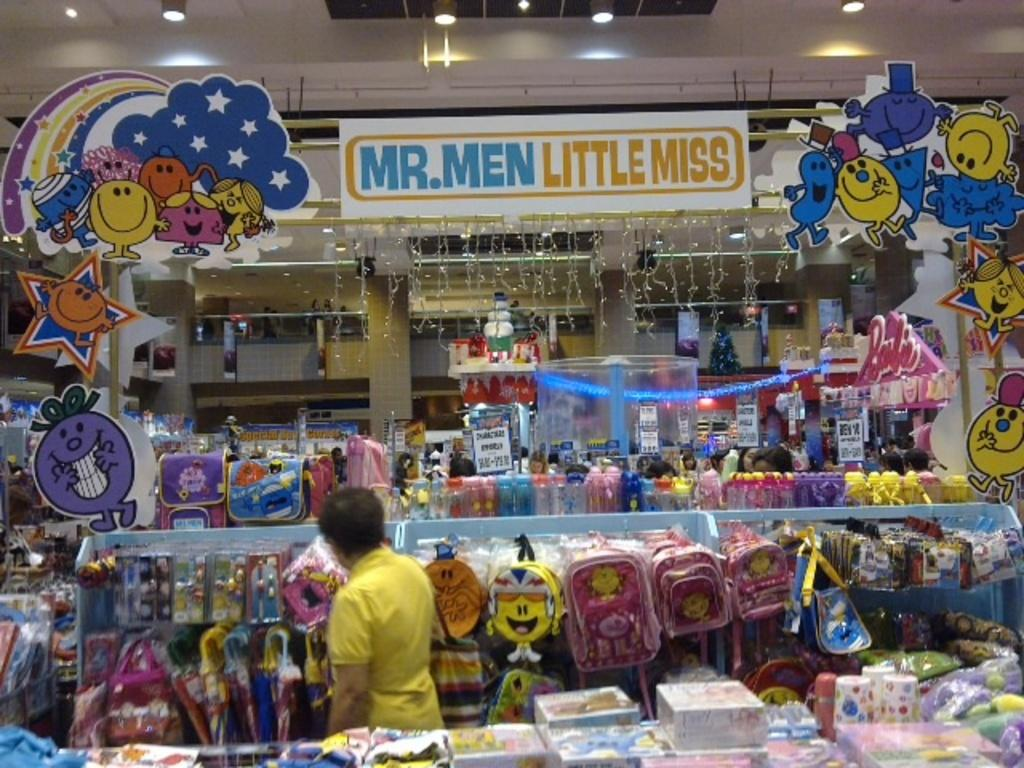Provide a one-sentence caption for the provided image. MR MEN LITTLE MISS STORE ISLE DISPLAY WITH TOYS. 